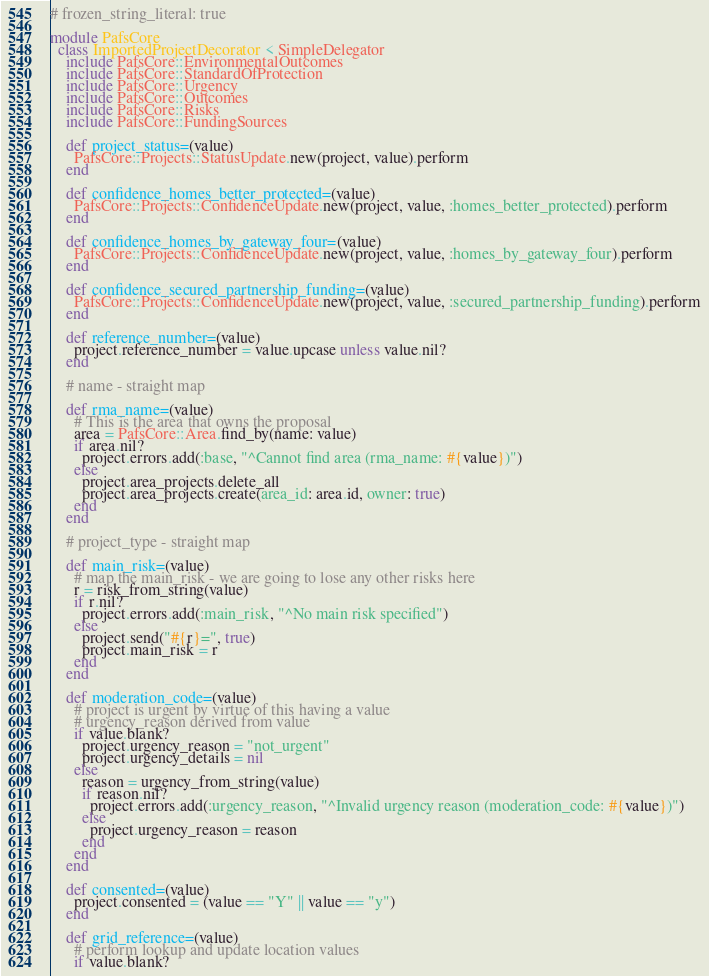<code> <loc_0><loc_0><loc_500><loc_500><_Ruby_># frozen_string_literal: true

module PafsCore
  class ImportedProjectDecorator < SimpleDelegator
    include PafsCore::EnvironmentalOutcomes
    include PafsCore::StandardOfProtection
    include PafsCore::Urgency
    include PafsCore::Outcomes
    include PafsCore::Risks
    include PafsCore::FundingSources

    def project_status=(value)
      PafsCore::Projects::StatusUpdate.new(project, value).perform
    end

    def confidence_homes_better_protected=(value)
      PafsCore::Projects::ConfidenceUpdate.new(project, value, :homes_better_protected).perform
    end

    def confidence_homes_by_gateway_four=(value)
      PafsCore::Projects::ConfidenceUpdate.new(project, value, :homes_by_gateway_four).perform
    end

    def confidence_secured_partnership_funding=(value)
      PafsCore::Projects::ConfidenceUpdate.new(project, value, :secured_partnership_funding).perform
    end

    def reference_number=(value)
      project.reference_number = value.upcase unless value.nil?
    end

    # name - straight map

    def rma_name=(value)
      # This is the area that owns the proposal
      area = PafsCore::Area.find_by(name: value)
      if area.nil?
        project.errors.add(:base, "^Cannot find area (rma_name: #{value})")
      else
        project.area_projects.delete_all
        project.area_projects.create(area_id: area.id, owner: true)
      end
    end

    # project_type - straight map

    def main_risk=(value)
      # map the main_risk - we are going to lose any other risks here
      r = risk_from_string(value)
      if r.nil?
        project.errors.add(:main_risk, "^No main risk specified")
      else
        project.send("#{r}=", true)
        project.main_risk = r
      end
    end

    def moderation_code=(value)
      # project is urgent by virtue of this having a value
      # urgency_reason derived from value
      if value.blank?
        project.urgency_reason = "not_urgent"
        project.urgency_details = nil
      else
        reason = urgency_from_string(value)
        if reason.nil?
          project.errors.add(:urgency_reason, "^Invalid urgency reason (moderation_code: #{value})")
        else
          project.urgency_reason = reason
        end
      end
    end

    def consented=(value)
      project.consented = (value == "Y" || value == "y")
    end

    def grid_reference=(value)
      # perform lookup and update location values
      if value.blank?</code> 